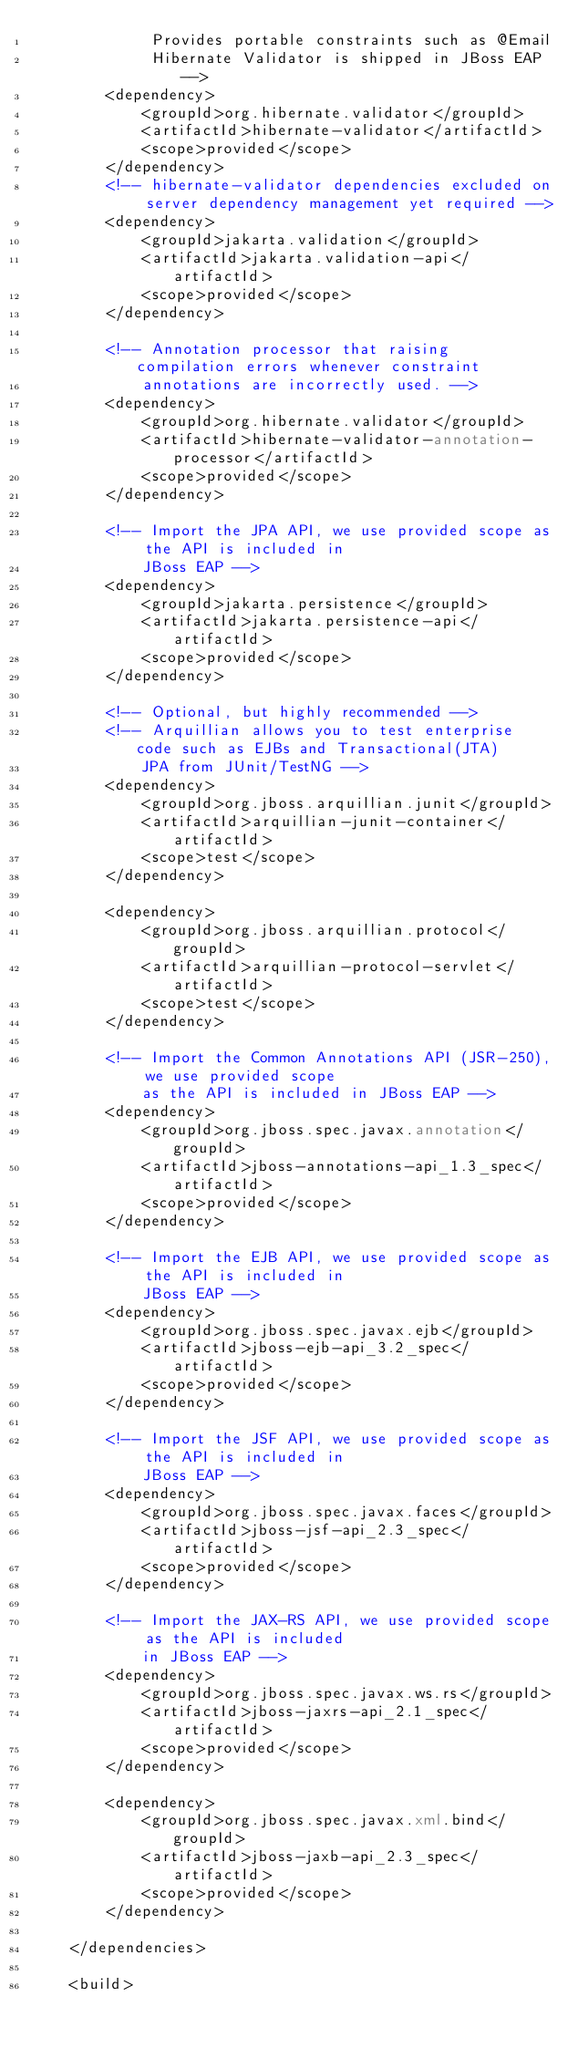<code> <loc_0><loc_0><loc_500><loc_500><_XML_>             Provides portable constraints such as @Email 
             Hibernate Validator is shipped in JBoss EAP -->
        <dependency>
            <groupId>org.hibernate.validator</groupId>
            <artifactId>hibernate-validator</artifactId>
            <scope>provided</scope>
        </dependency>
        <!-- hibernate-validator dependencies excluded on server dependency management yet required -->
        <dependency>
            <groupId>jakarta.validation</groupId>
            <artifactId>jakarta.validation-api</artifactId>
            <scope>provided</scope>
        </dependency>

        <!-- Annotation processor that raising compilation errors whenever constraint
            annotations are incorrectly used. -->
        <dependency>
            <groupId>org.hibernate.validator</groupId>
            <artifactId>hibernate-validator-annotation-processor</artifactId>
            <scope>provided</scope>
        </dependency>

        <!-- Import the JPA API, we use provided scope as the API is included in
            JBoss EAP -->
        <dependency>
            <groupId>jakarta.persistence</groupId>
            <artifactId>jakarta.persistence-api</artifactId>
            <scope>provided</scope>
        </dependency>

        <!-- Optional, but highly recommended -->
        <!-- Arquillian allows you to test enterprise code such as EJBs and Transactional(JTA)
            JPA from JUnit/TestNG -->
        <dependency>
            <groupId>org.jboss.arquillian.junit</groupId>
            <artifactId>arquillian-junit-container</artifactId>
            <scope>test</scope>
        </dependency>

        <dependency>
            <groupId>org.jboss.arquillian.protocol</groupId>
            <artifactId>arquillian-protocol-servlet</artifactId>
            <scope>test</scope>
        </dependency>

        <!-- Import the Common Annotations API (JSR-250), we use provided scope
            as the API is included in JBoss EAP -->
        <dependency>
            <groupId>org.jboss.spec.javax.annotation</groupId>
            <artifactId>jboss-annotations-api_1.3_spec</artifactId>
            <scope>provided</scope>
        </dependency>

        <!-- Import the EJB API, we use provided scope as the API is included in
            JBoss EAP -->
        <dependency>
            <groupId>org.jboss.spec.javax.ejb</groupId>
            <artifactId>jboss-ejb-api_3.2_spec</artifactId>
            <scope>provided</scope>
        </dependency>

        <!-- Import the JSF API, we use provided scope as the API is included in
            JBoss EAP -->
        <dependency>
            <groupId>org.jboss.spec.javax.faces</groupId>
            <artifactId>jboss-jsf-api_2.3_spec</artifactId>
            <scope>provided</scope>
        </dependency>

        <!-- Import the JAX-RS API, we use provided scope as the API is included
            in JBoss EAP -->
        <dependency>
            <groupId>org.jboss.spec.javax.ws.rs</groupId>
            <artifactId>jboss-jaxrs-api_2.1_spec</artifactId>
            <scope>provided</scope>
        </dependency>

        <dependency>
            <groupId>org.jboss.spec.javax.xml.bind</groupId>
            <artifactId>jboss-jaxb-api_2.3_spec</artifactId>
            <scope>provided</scope>
        </dependency>

    </dependencies>

    <build></code> 